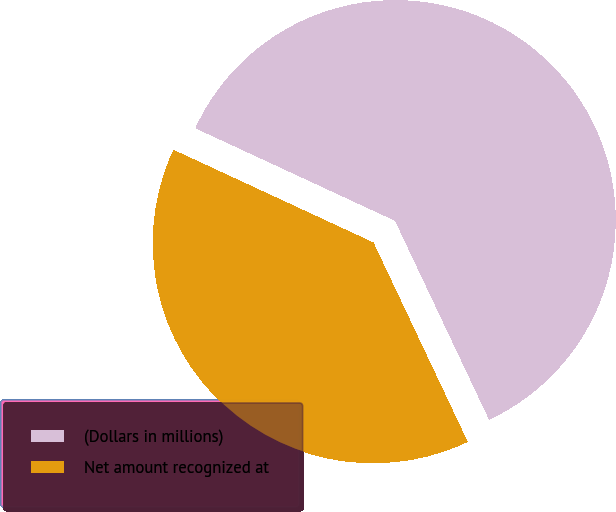<chart> <loc_0><loc_0><loc_500><loc_500><pie_chart><fcel>(Dollars in millions)<fcel>Net amount recognized at<nl><fcel>61.06%<fcel>38.94%<nl></chart> 